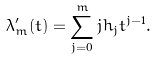Convert formula to latex. <formula><loc_0><loc_0><loc_500><loc_500>\lambda ^ { \prime } _ { m } ( t ) = \sum _ { j = 0 } ^ { m } j h _ { j } t ^ { j - 1 } .</formula> 